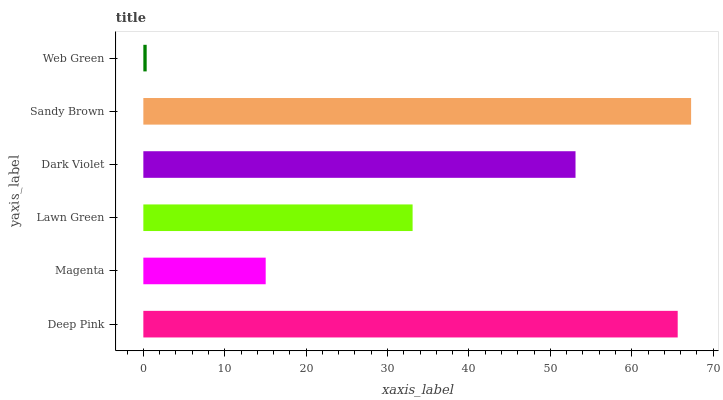Is Web Green the minimum?
Answer yes or no. Yes. Is Sandy Brown the maximum?
Answer yes or no. Yes. Is Magenta the minimum?
Answer yes or no. No. Is Magenta the maximum?
Answer yes or no. No. Is Deep Pink greater than Magenta?
Answer yes or no. Yes. Is Magenta less than Deep Pink?
Answer yes or no. Yes. Is Magenta greater than Deep Pink?
Answer yes or no. No. Is Deep Pink less than Magenta?
Answer yes or no. No. Is Dark Violet the high median?
Answer yes or no. Yes. Is Lawn Green the low median?
Answer yes or no. Yes. Is Sandy Brown the high median?
Answer yes or no. No. Is Deep Pink the low median?
Answer yes or no. No. 